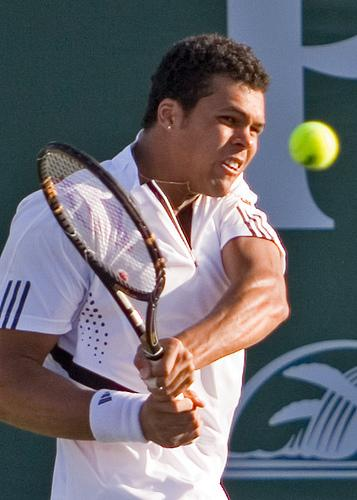This playing is making what shot?

Choices:
A) forehand
B) serve
C) lob
D) backhand backhand 